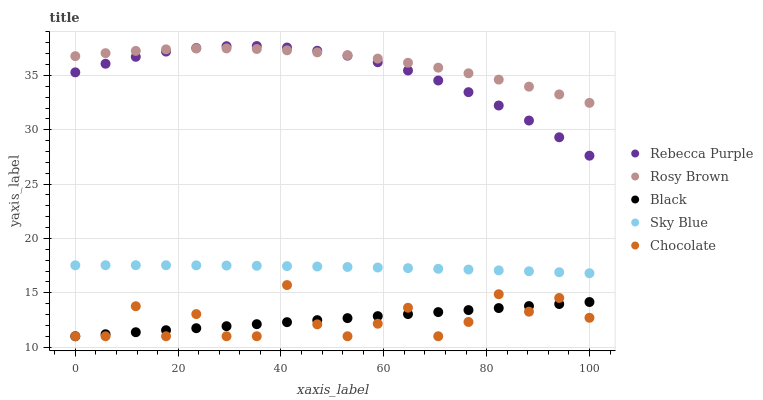Does Chocolate have the minimum area under the curve?
Answer yes or no. Yes. Does Rosy Brown have the maximum area under the curve?
Answer yes or no. Yes. Does Black have the minimum area under the curve?
Answer yes or no. No. Does Black have the maximum area under the curve?
Answer yes or no. No. Is Black the smoothest?
Answer yes or no. Yes. Is Chocolate the roughest?
Answer yes or no. Yes. Is Rosy Brown the smoothest?
Answer yes or no. No. Is Rosy Brown the roughest?
Answer yes or no. No. Does Black have the lowest value?
Answer yes or no. Yes. Does Rosy Brown have the lowest value?
Answer yes or no. No. Does Rebecca Purple have the highest value?
Answer yes or no. Yes. Does Rosy Brown have the highest value?
Answer yes or no. No. Is Black less than Sky Blue?
Answer yes or no. Yes. Is Rosy Brown greater than Sky Blue?
Answer yes or no. Yes. Does Chocolate intersect Black?
Answer yes or no. Yes. Is Chocolate less than Black?
Answer yes or no. No. Is Chocolate greater than Black?
Answer yes or no. No. Does Black intersect Sky Blue?
Answer yes or no. No. 